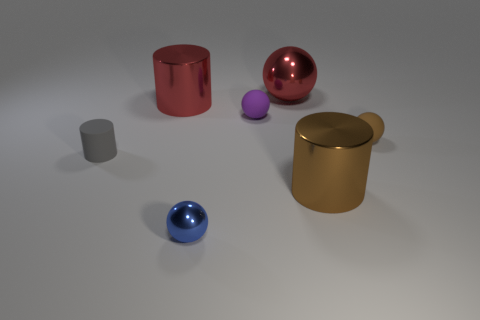What number of large red metal spheres are behind the rubber object to the left of the large thing that is on the left side of the red sphere? There is one large red metal sphere located behind the rubber object, which appears to be a grey cylinder, to the left of the large yellow cylindrical container. 